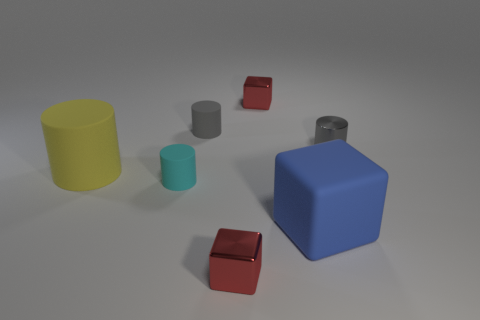What material is the other small cylinder that is the same color as the metal cylinder?
Give a very brief answer. Rubber. What number of other objects are the same color as the metallic cylinder?
Provide a short and direct response. 1. What color is the large rubber object right of the cyan cylinder that is in front of the big yellow thing?
Make the answer very short. Blue. The large blue thing is what shape?
Your answer should be very brief. Cube. Is the size of the red block that is behind the yellow matte object the same as the large cube?
Provide a short and direct response. No. Are there any large blue blocks that have the same material as the yellow thing?
Provide a succinct answer. Yes. How many objects are either metallic things that are in front of the big yellow matte cylinder or large objects?
Offer a terse response. 3. Is there a red rubber block?
Provide a short and direct response. No. What shape is the tiny object that is both behind the metal cylinder and right of the gray matte cylinder?
Keep it short and to the point. Cube. What size is the red cube behind the large matte cylinder?
Keep it short and to the point. Small. 